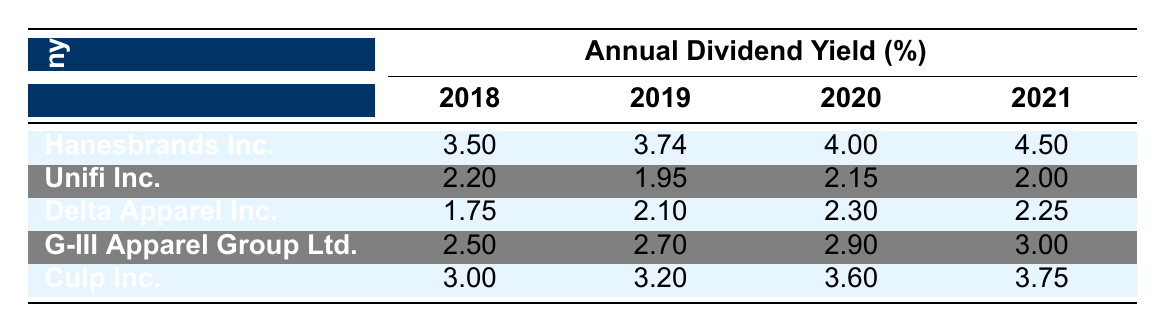What was Hanesbrands Inc.'s dividend yield in 2021? From the table, we look for the row corresponding to Hanesbrands Inc. and find the column under the year 2021. The dividend yield listed is 4.50.
Answer: 4.50 What is the annual dividend yield of Unifi Inc. in 2019? By examining the row for Unifi Inc. and checking the column for 2019, we find that the dividend yield is 1.95.
Answer: 1.95 Which company had the highest dividend yield in 2020? We must compare the values in the 2020 column for all companies. Hanesbrands Inc. has 4.00, Unifi Inc. has 2.15, Delta Apparel Inc. has 2.30, G-III Apparel Group Ltd. has 2.90, and Culp Inc. has 3.60. The highest value is 4.00 from Hanesbrands Inc.
Answer: Hanesbrands Inc Was Delta Apparel Inc.'s dividend yield consistent over the years 2018 to 2021? We need to check the values for Delta Apparel Inc. from 2018 (1.75), 2019 (2.10), 2020 (2.30), and 2021 (2.25). The yields fluctuate, showing an increase until 2020 and a slight decrease in 2021, indicating inconsistency.
Answer: No What is the average dividend yield for G-III Apparel Group Ltd. from 2018 to 2021? First, we sum the dividend yields: 2.50 + 2.70 + 2.90 + 3.00 = 11.10. Then, we divide by the number of years, which is 4. So, 11.10 / 4 = 2.775.
Answer: 2.775 Which company improved its dividend yield the most from 2018 to 2021? We calculate the change for each company: Hanesbrands Inc. increased by 1.00 (from 3.50 to 4.50), Unifi Inc. decreased by 0.20 (from 2.20 to 2.00), Delta Apparel Inc. increased by 0.50 (from 1.75 to 2.25), G-III Apparel Group Ltd. increased by 0.50 (from 2.50 to 3.00), and Culp Inc. increased by 0.75 (from 3.00 to 3.75). The largest increase was 1.00 for Hanesbrands Inc.
Answer: Hanesbrands Inc 